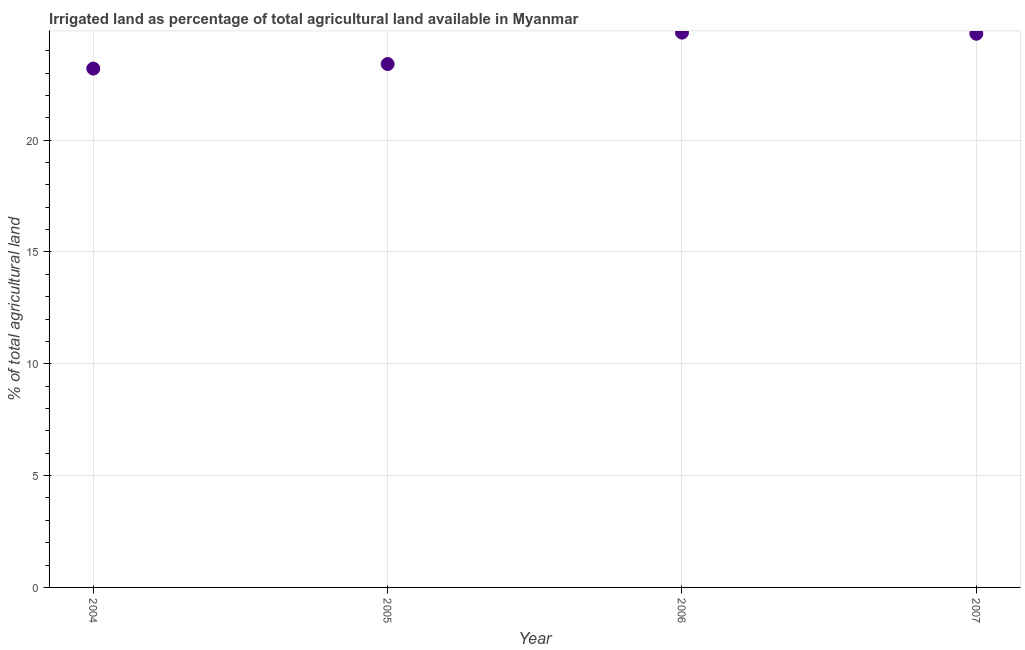What is the percentage of agricultural irrigated land in 2004?
Give a very brief answer. 23.2. Across all years, what is the maximum percentage of agricultural irrigated land?
Make the answer very short. 24.81. Across all years, what is the minimum percentage of agricultural irrigated land?
Keep it short and to the point. 23.2. In which year was the percentage of agricultural irrigated land maximum?
Offer a very short reply. 2006. What is the sum of the percentage of agricultural irrigated land?
Provide a short and direct response. 96.17. What is the difference between the percentage of agricultural irrigated land in 2004 and 2006?
Give a very brief answer. -1.61. What is the average percentage of agricultural irrigated land per year?
Your answer should be very brief. 24.04. What is the median percentage of agricultural irrigated land?
Offer a terse response. 24.08. Do a majority of the years between 2006 and 2004 (inclusive) have percentage of agricultural irrigated land greater than 12 %?
Give a very brief answer. No. What is the ratio of the percentage of agricultural irrigated land in 2004 to that in 2006?
Make the answer very short. 0.94. Is the percentage of agricultural irrigated land in 2005 less than that in 2007?
Give a very brief answer. Yes. What is the difference between the highest and the second highest percentage of agricultural irrigated land?
Offer a very short reply. 0.05. What is the difference between the highest and the lowest percentage of agricultural irrigated land?
Your answer should be very brief. 1.61. In how many years, is the percentage of agricultural irrigated land greater than the average percentage of agricultural irrigated land taken over all years?
Offer a very short reply. 2. How many dotlines are there?
Offer a very short reply. 1. How many years are there in the graph?
Offer a terse response. 4. What is the difference between two consecutive major ticks on the Y-axis?
Offer a very short reply. 5. Are the values on the major ticks of Y-axis written in scientific E-notation?
Offer a terse response. No. Does the graph contain any zero values?
Keep it short and to the point. No. What is the title of the graph?
Give a very brief answer. Irrigated land as percentage of total agricultural land available in Myanmar. What is the label or title of the Y-axis?
Provide a short and direct response. % of total agricultural land. What is the % of total agricultural land in 2004?
Your answer should be compact. 23.2. What is the % of total agricultural land in 2005?
Your answer should be compact. 23.4. What is the % of total agricultural land in 2006?
Ensure brevity in your answer.  24.81. What is the % of total agricultural land in 2007?
Keep it short and to the point. 24.76. What is the difference between the % of total agricultural land in 2004 and 2005?
Make the answer very short. -0.2. What is the difference between the % of total agricultural land in 2004 and 2006?
Provide a short and direct response. -1.61. What is the difference between the % of total agricultural land in 2004 and 2007?
Offer a terse response. -1.56. What is the difference between the % of total agricultural land in 2005 and 2006?
Provide a succinct answer. -1.4. What is the difference between the % of total agricultural land in 2005 and 2007?
Give a very brief answer. -1.35. What is the difference between the % of total agricultural land in 2006 and 2007?
Provide a short and direct response. 0.05. What is the ratio of the % of total agricultural land in 2004 to that in 2005?
Your answer should be very brief. 0.99. What is the ratio of the % of total agricultural land in 2004 to that in 2006?
Your answer should be compact. 0.94. What is the ratio of the % of total agricultural land in 2004 to that in 2007?
Provide a short and direct response. 0.94. What is the ratio of the % of total agricultural land in 2005 to that in 2006?
Provide a succinct answer. 0.94. What is the ratio of the % of total agricultural land in 2005 to that in 2007?
Offer a very short reply. 0.94. 